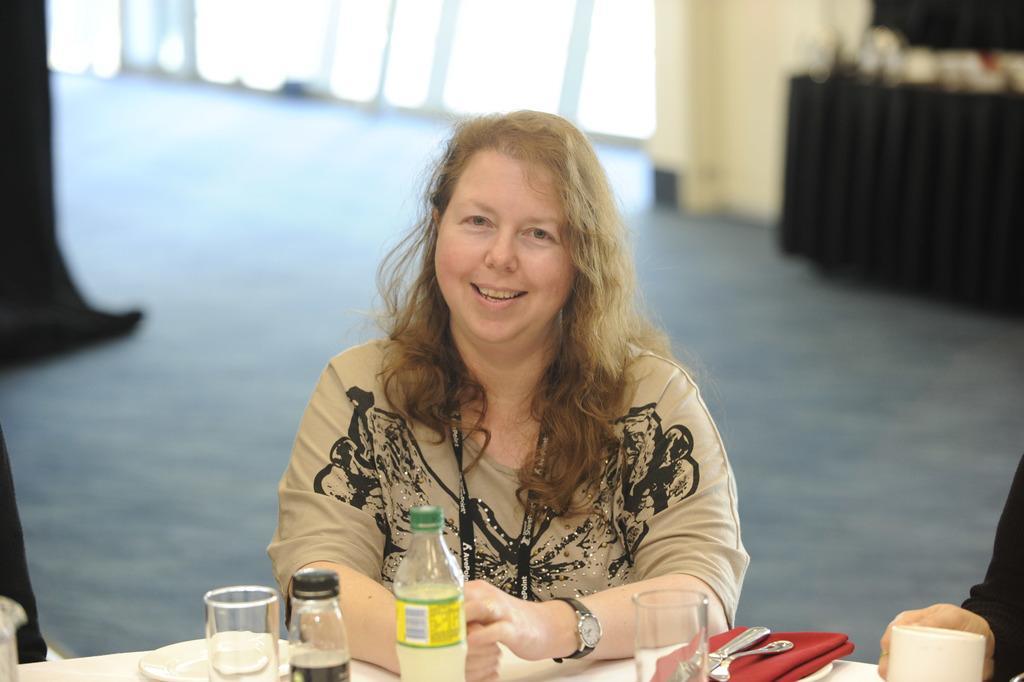Could you give a brief overview of what you see in this image? In this picture there is a woman sitting on the chair, she is smiling and she wore a watch on to her left hand, there is a table in front of a with a bottle, there is a plate, water glass there some napkins, forks and spoons. 